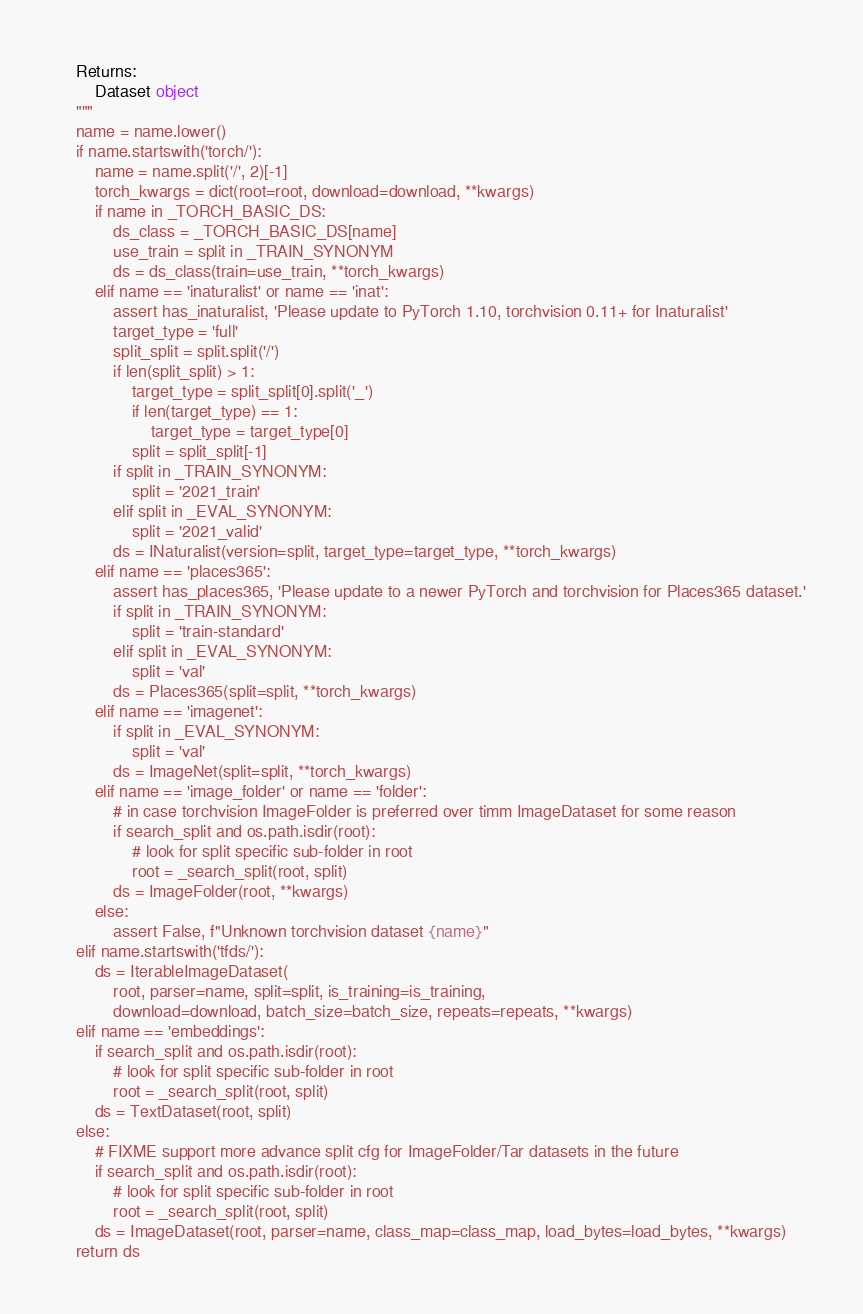<code> <loc_0><loc_0><loc_500><loc_500><_Python_>
    Returns:
        Dataset object
    """
    name = name.lower()
    if name.startswith('torch/'):
        name = name.split('/', 2)[-1]
        torch_kwargs = dict(root=root, download=download, **kwargs)
        if name in _TORCH_BASIC_DS:
            ds_class = _TORCH_BASIC_DS[name]
            use_train = split in _TRAIN_SYNONYM
            ds = ds_class(train=use_train, **torch_kwargs)
        elif name == 'inaturalist' or name == 'inat':
            assert has_inaturalist, 'Please update to PyTorch 1.10, torchvision 0.11+ for Inaturalist'
            target_type = 'full'
            split_split = split.split('/')
            if len(split_split) > 1:
                target_type = split_split[0].split('_')
                if len(target_type) == 1:
                    target_type = target_type[0]
                split = split_split[-1]
            if split in _TRAIN_SYNONYM:
                split = '2021_train'
            elif split in _EVAL_SYNONYM:
                split = '2021_valid'
            ds = INaturalist(version=split, target_type=target_type, **torch_kwargs)
        elif name == 'places365':
            assert has_places365, 'Please update to a newer PyTorch and torchvision for Places365 dataset.'
            if split in _TRAIN_SYNONYM:
                split = 'train-standard'
            elif split in _EVAL_SYNONYM:
                split = 'val'
            ds = Places365(split=split, **torch_kwargs)
        elif name == 'imagenet':
            if split in _EVAL_SYNONYM:
                split = 'val'
            ds = ImageNet(split=split, **torch_kwargs)
        elif name == 'image_folder' or name == 'folder':
            # in case torchvision ImageFolder is preferred over timm ImageDataset for some reason
            if search_split and os.path.isdir(root):
                # look for split specific sub-folder in root
                root = _search_split(root, split)
            ds = ImageFolder(root, **kwargs)
        else:
            assert False, f"Unknown torchvision dataset {name}"
    elif name.startswith('tfds/'):
        ds = IterableImageDataset(
            root, parser=name, split=split, is_training=is_training,
            download=download, batch_size=batch_size, repeats=repeats, **kwargs)
    elif name == 'embeddings':
        if search_split and os.path.isdir(root):
            # look for split specific sub-folder in root
            root = _search_split(root, split)
        ds = TextDataset(root, split)
    else:
        # FIXME support more advance split cfg for ImageFolder/Tar datasets in the future
        if search_split and os.path.isdir(root):
            # look for split specific sub-folder in root
            root = _search_split(root, split)
        ds = ImageDataset(root, parser=name, class_map=class_map, load_bytes=load_bytes, **kwargs)
    return ds
</code> 